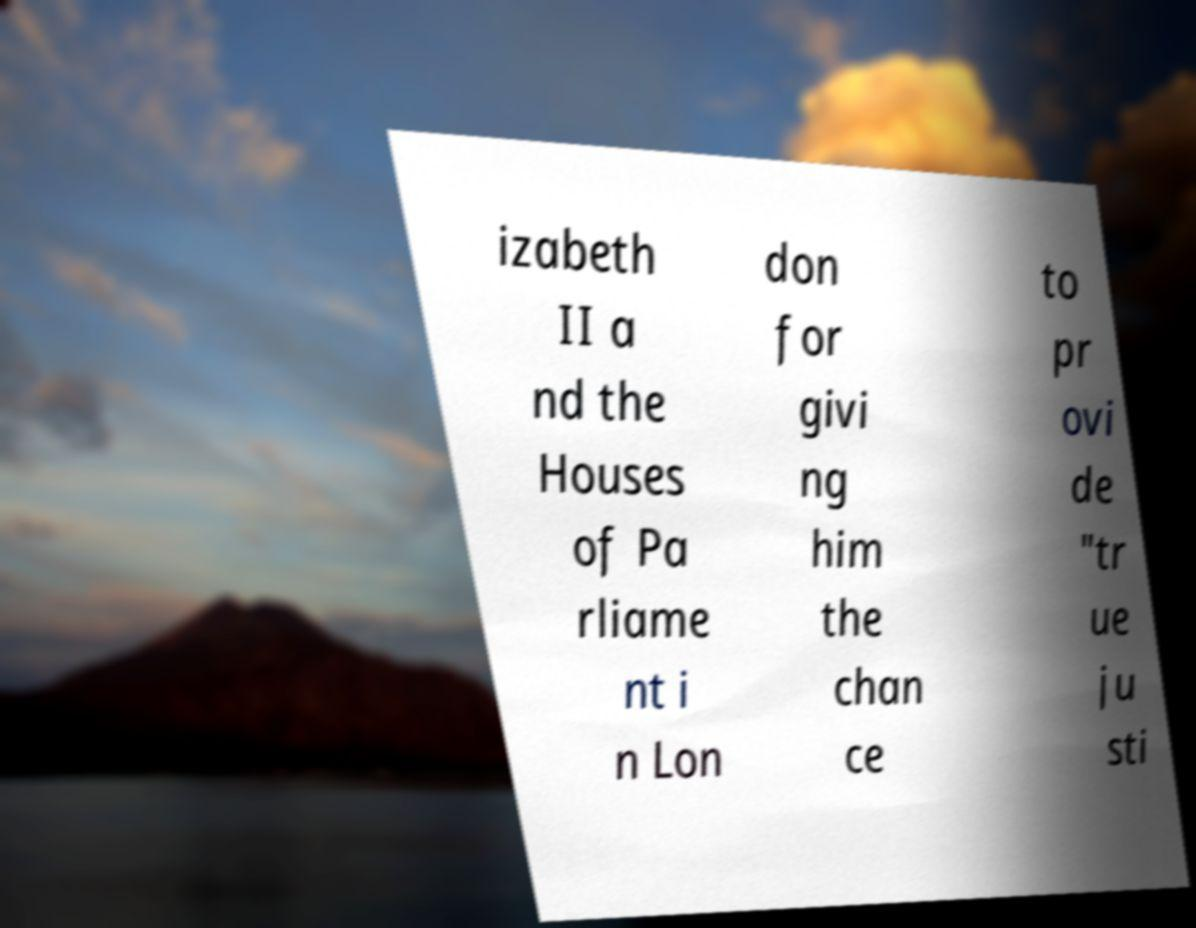Can you accurately transcribe the text from the provided image for me? izabeth II a nd the Houses of Pa rliame nt i n Lon don for givi ng him the chan ce to pr ovi de "tr ue ju sti 